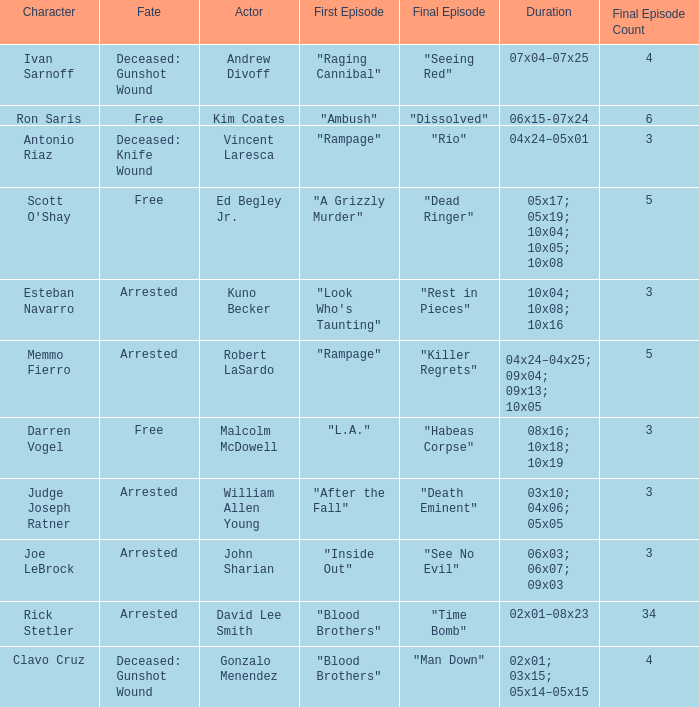What's the total number of final epbeingode count with first epbeingode being "l.a." 1.0. 